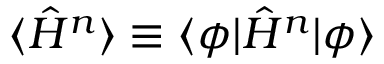Convert formula to latex. <formula><loc_0><loc_0><loc_500><loc_500>\langle \hat { H } ^ { n } \rangle \equiv \langle \phi | \hat { H } ^ { n } | \phi \rangle</formula> 